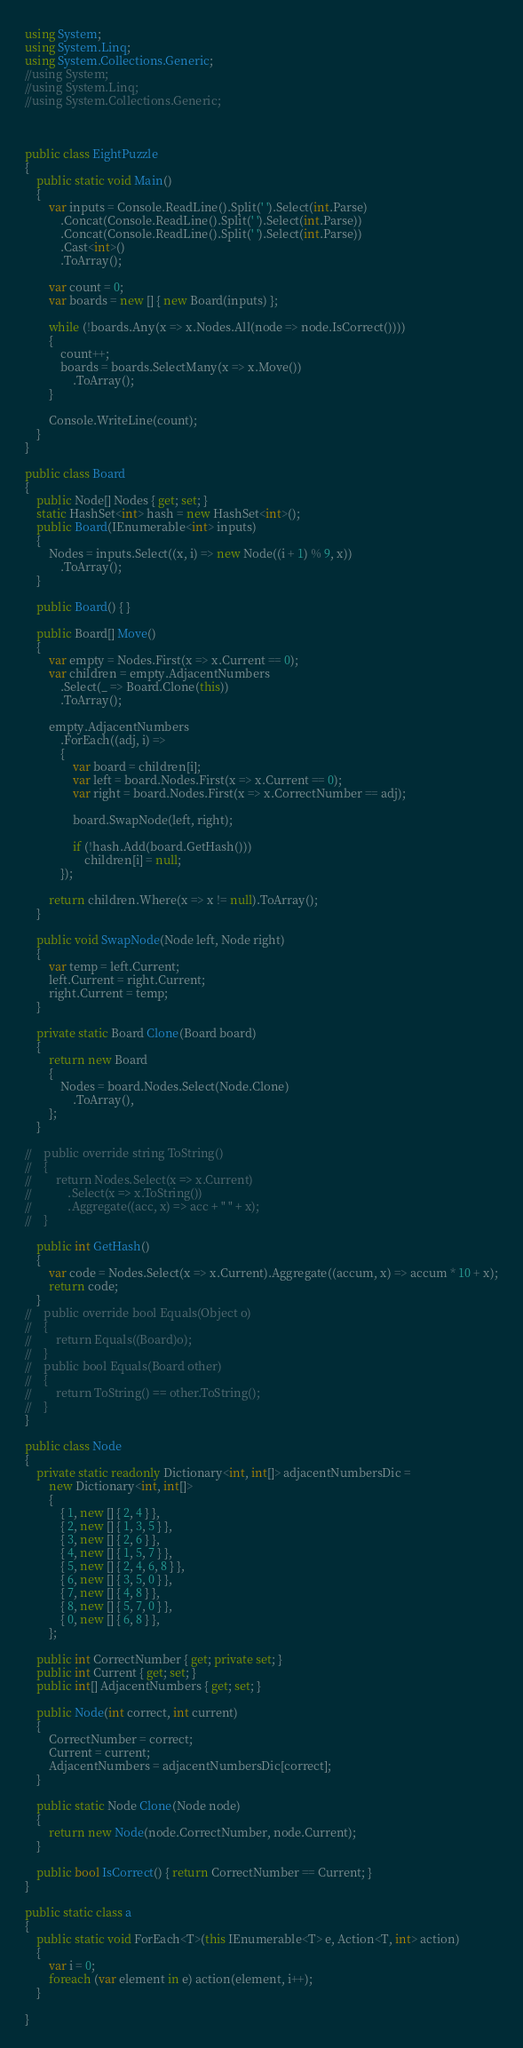Convert code to text. <code><loc_0><loc_0><loc_500><loc_500><_C#_>using System;
using System.Linq;
using System.Collections.Generic;
//using System;
//using System.Linq;
//using System.Collections.Generic;



public class EightPuzzle
{
    public static void Main()
    {
        var inputs = Console.ReadLine().Split(' ').Select(int.Parse)
            .Concat(Console.ReadLine().Split(' ').Select(int.Parse))
            .Concat(Console.ReadLine().Split(' ').Select(int.Parse))
            .Cast<int>()
            .ToArray();
        
        var count = 0;
        var boards = new [] { new Board(inputs) };
        
        while (!boards.Any(x => x.Nodes.All(node => node.IsCorrect())))
        {
            count++;
            boards = boards.SelectMany(x => x.Move())
                .ToArray();
        }
        
        Console.WriteLine(count);
    }
}

public class Board
{
    public Node[] Nodes { get; set; }
    static HashSet<int> hash = new HashSet<int>();
    public Board(IEnumerable<int> inputs)
    {
        Nodes = inputs.Select((x, i) => new Node((i + 1) % 9, x))
            .ToArray();
    }
    
    public Board() { }
    
    public Board[] Move()
    {
        var empty = Nodes.First(x => x.Current == 0);
        var children = empty.AdjacentNumbers
            .Select(_ => Board.Clone(this))
            .ToArray();
        
        empty.AdjacentNumbers
            .ForEach((adj, i) =>
            {
                var board = children[i];
                var left = board.Nodes.First(x => x.Current == 0);
                var right = board.Nodes.First(x => x.CorrectNumber == adj);
                
                board.SwapNode(left, right);
                
                if (!hash.Add(board.GetHash()))
                    children[i] = null;
            });
        
        return children.Where(x => x != null).ToArray();
    }
    
    public void SwapNode(Node left, Node right)
    {
        var temp = left.Current;
        left.Current = right.Current;
        right.Current = temp;
    }
    
    private static Board Clone(Board board)
    {
        return new Board
        {
            Nodes = board.Nodes.Select(Node.Clone)
                .ToArray(),
        };
    }

//    public override string ToString()
//    {
//        return Nodes.Select(x => x.Current)
//            .Select(x => x.ToString())
//            .Aggregate((acc, x) => acc + " " + x);
//    }
    
    public int GetHash()
    {
        var code = Nodes.Select(x => x.Current).Aggregate((accum, x) => accum * 10 + x);
        return code;
    }
//    public override bool Equals(Object o)
//    {
//        return Equals((Board)o);
//    }
//    public bool Equals(Board other)
//    {
//        return ToString() == other.ToString();
//    }
}

public class Node
{
    private static readonly Dictionary<int, int[]> adjacentNumbersDic =
        new Dictionary<int, int[]>
        {
            { 1, new [] { 2, 4 } },
            { 2, new [] { 1, 3, 5 } },
            { 3, new [] { 2, 6 } },
            { 4, new [] { 1, 5, 7 } },
            { 5, new [] { 2, 4, 6, 8 } },
            { 6, new [] { 3, 5, 0 } },
            { 7, new [] { 4, 8 } },
            { 8, new [] { 5, 7, 0 } },
            { 0, new [] { 6, 8 } },
        };

    public int CorrectNumber { get; private set; }    
    public int Current { get; set; }
    public int[] AdjacentNumbers { get; set; }

    public Node(int correct, int current)
    {
        CorrectNumber = correct;
        Current = current;
        AdjacentNumbers = adjacentNumbersDic[correct];
    }
    
    public static Node Clone(Node node)
    {
        return new Node(node.CorrectNumber, node.Current);
    }
    
    public bool IsCorrect() { return CorrectNumber == Current; }
}

public static class a
{
	public static void ForEach<T>(this IEnumerable<T> e, Action<T, int> action)
	{
		var i = 0;
		foreach (var element in e) action(element, i++);
	}

}</code> 